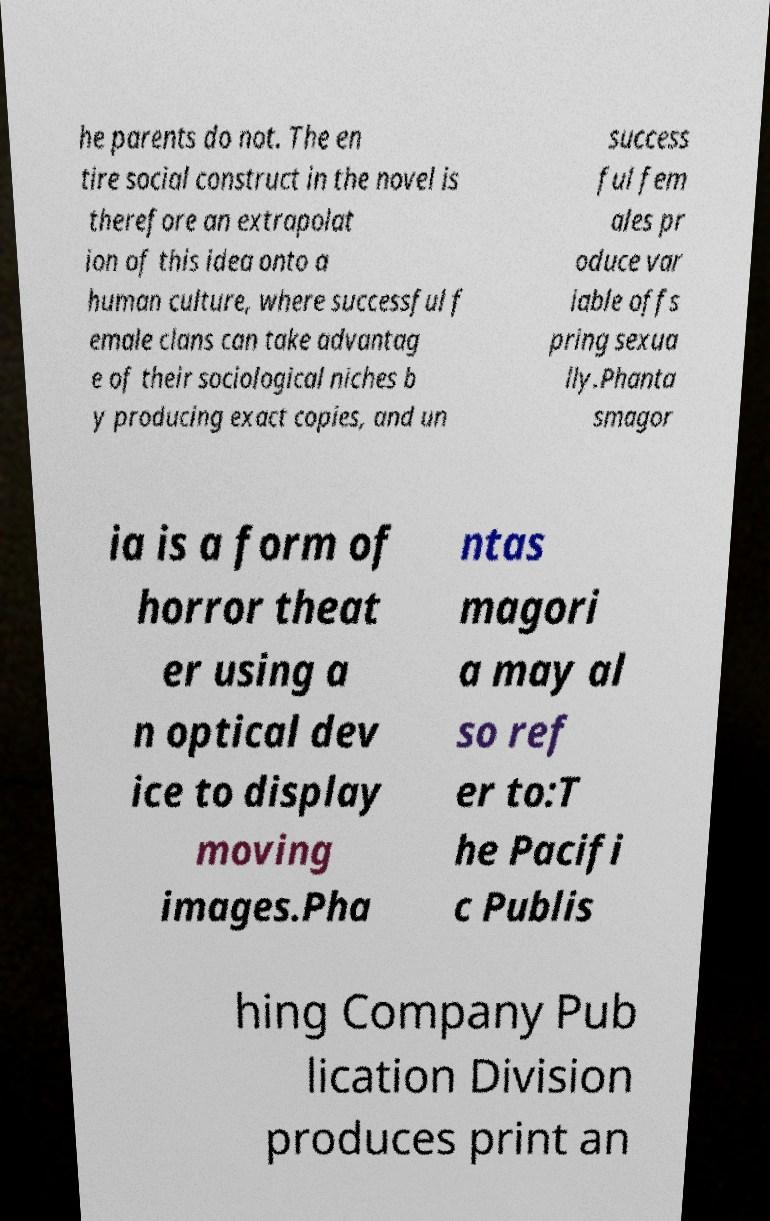There's text embedded in this image that I need extracted. Can you transcribe it verbatim? he parents do not. The en tire social construct in the novel is therefore an extrapolat ion of this idea onto a human culture, where successful f emale clans can take advantag e of their sociological niches b y producing exact copies, and un success ful fem ales pr oduce var iable offs pring sexua lly.Phanta smagor ia is a form of horror theat er using a n optical dev ice to display moving images.Pha ntas magori a may al so ref er to:T he Pacifi c Publis hing Company Pub lication Division produces print an 